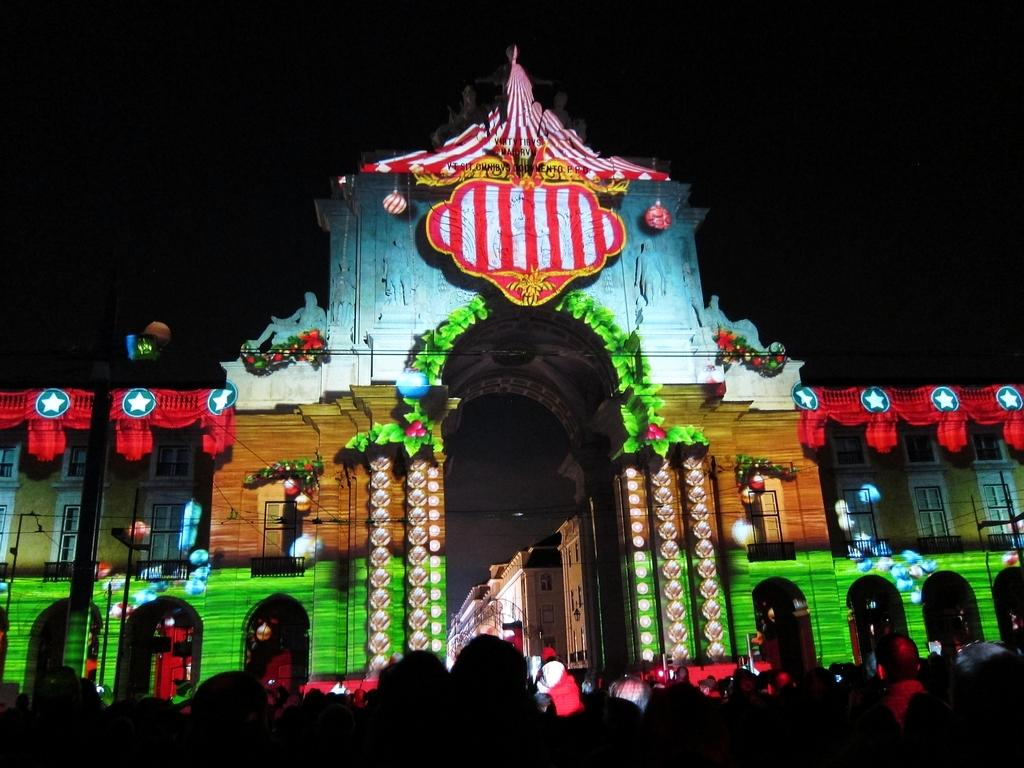What is the main subject of the image? The main subject of the image is the entrance of a building. How can the entrance be described? The entrance is colorful. What can be seen in the background of the image? The sky is dark in the image. Can you hear the bun in the image? There is no bun present in the image, and therefore no sound can be heard from it. 